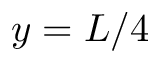<formula> <loc_0><loc_0><loc_500><loc_500>y = L / 4</formula> 